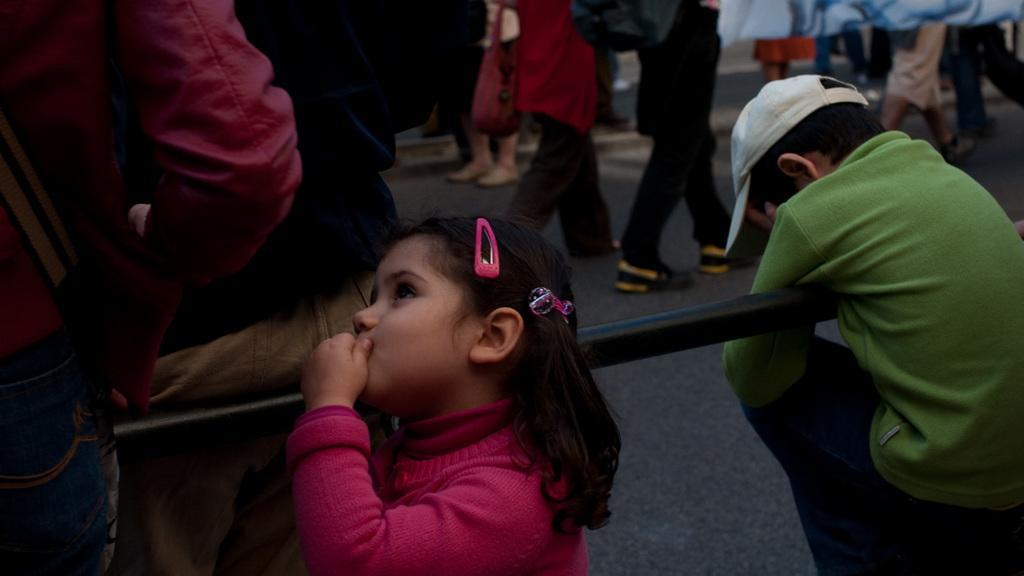How would you summarize this image in a sentence or two? In this picture we can see a group of people where some are standing at rod and some are walking on the road. 